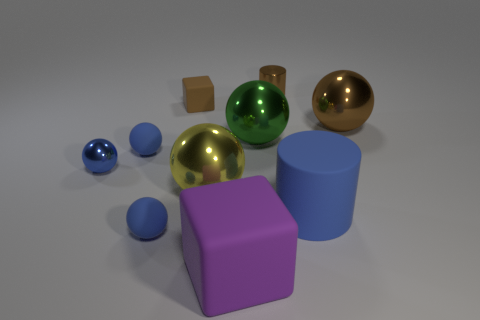What is the material of the large brown thing?
Ensure brevity in your answer.  Metal. What number of other things are made of the same material as the large cylinder?
Ensure brevity in your answer.  4. What number of red rubber balls are there?
Provide a short and direct response. 0. There is a yellow thing that is the same shape as the big green metal thing; what is it made of?
Ensure brevity in your answer.  Metal. Is the material of the block behind the yellow metallic ball the same as the large cube?
Ensure brevity in your answer.  Yes. Are there more big spheres that are right of the large cylinder than big cylinders that are on the left side of the yellow thing?
Ensure brevity in your answer.  Yes. The metallic cylinder is what size?
Make the answer very short. Small. The large purple object that is the same material as the tiny brown cube is what shape?
Your response must be concise. Cube. Does the brown object left of the yellow shiny ball have the same shape as the large yellow object?
Give a very brief answer. No. How many objects are large shiny objects or large green shiny things?
Give a very brief answer. 3. 